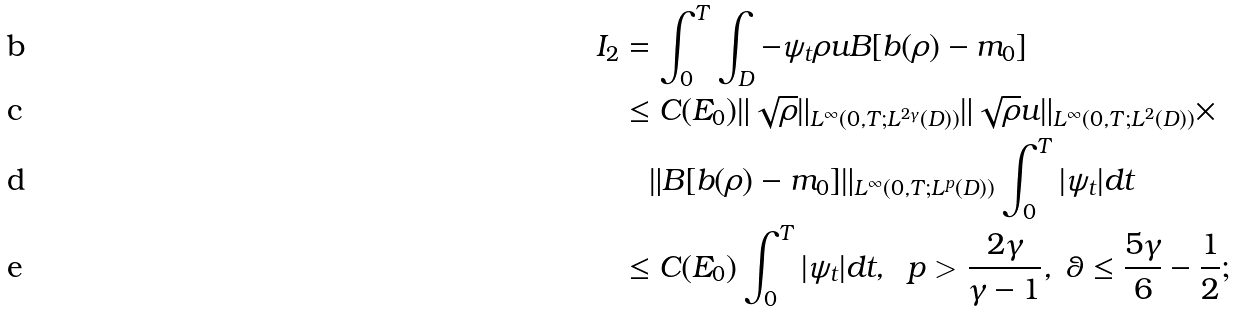Convert formula to latex. <formula><loc_0><loc_0><loc_500><loc_500>I _ { 2 } & = \int ^ { T } _ { 0 } \int _ { D } - \psi _ { t } \rho u B [ b ( \rho ) - m _ { 0 } ] \\ & \leq C ( E _ { 0 } ) \| \sqrt { \rho } \| _ { L ^ { \infty } ( 0 , T ; L ^ { 2 \gamma } ( D ) ) } \| \sqrt { \rho } u \| _ { L ^ { \infty } ( 0 , T ; L ^ { 2 } ( D ) ) } \times \\ & \quad \| B [ b ( \rho ) - m _ { 0 } ] \| _ { L ^ { \infty } ( 0 , T ; L ^ { p } ( D ) ) } \int ^ { T } _ { 0 } | \psi _ { t } | d t \\ & \leq C ( E _ { 0 } ) \int ^ { T } _ { 0 } | \psi _ { t } | d t , \ \ p > \frac { 2 \gamma } { \gamma - 1 } , \ \theta \leq \frac { 5 \gamma } { 6 } - \frac { 1 } { 2 } ;</formula> 